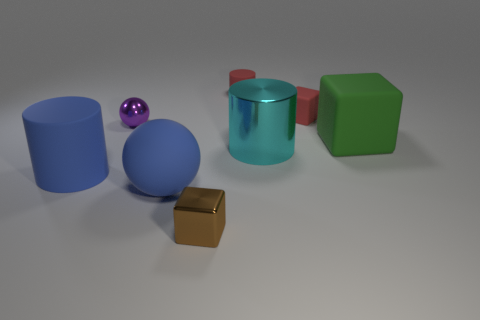Subtract all matte cylinders. How many cylinders are left? 1 Subtract 1 blocks. How many blocks are left? 2 Subtract all blue spheres. Subtract all brown blocks. How many spheres are left? 1 Subtract all red spheres. How many red cylinders are left? 1 Subtract all red rubber cylinders. Subtract all matte balls. How many objects are left? 6 Add 4 green matte objects. How many green matte objects are left? 5 Add 7 red matte cylinders. How many red matte cylinders exist? 8 Add 1 big blue matte cylinders. How many objects exist? 9 Subtract all cyan cylinders. How many cylinders are left? 2 Subtract 0 green cylinders. How many objects are left? 8 